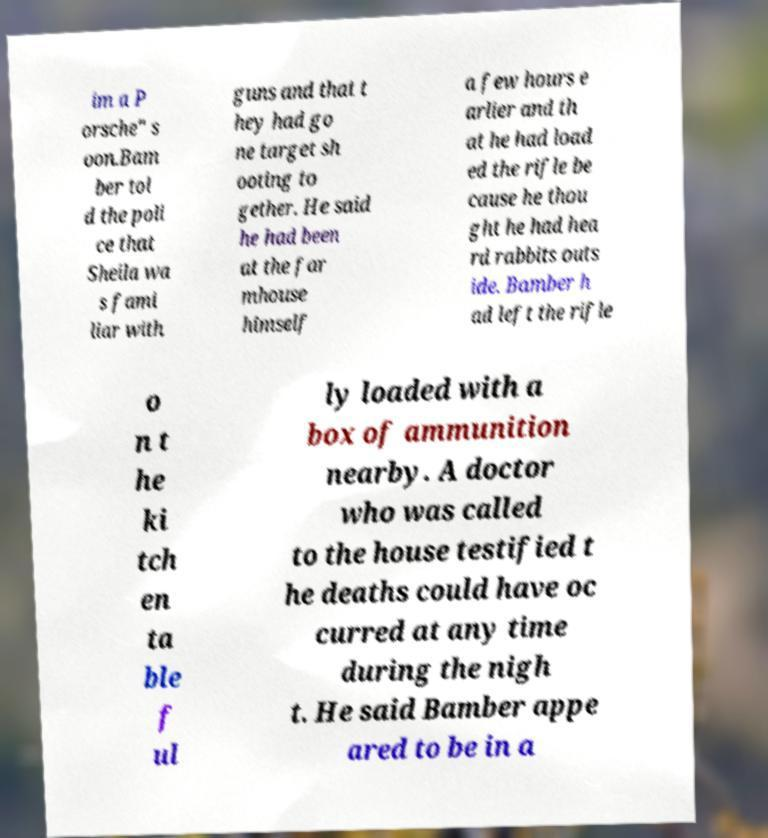For documentation purposes, I need the text within this image transcribed. Could you provide that? im a P orsche" s oon.Bam ber tol d the poli ce that Sheila wa s fami liar with guns and that t hey had go ne target sh ooting to gether. He said he had been at the far mhouse himself a few hours e arlier and th at he had load ed the rifle be cause he thou ght he had hea rd rabbits outs ide. Bamber h ad left the rifle o n t he ki tch en ta ble f ul ly loaded with a box of ammunition nearby. A doctor who was called to the house testified t he deaths could have oc curred at any time during the nigh t. He said Bamber appe ared to be in a 